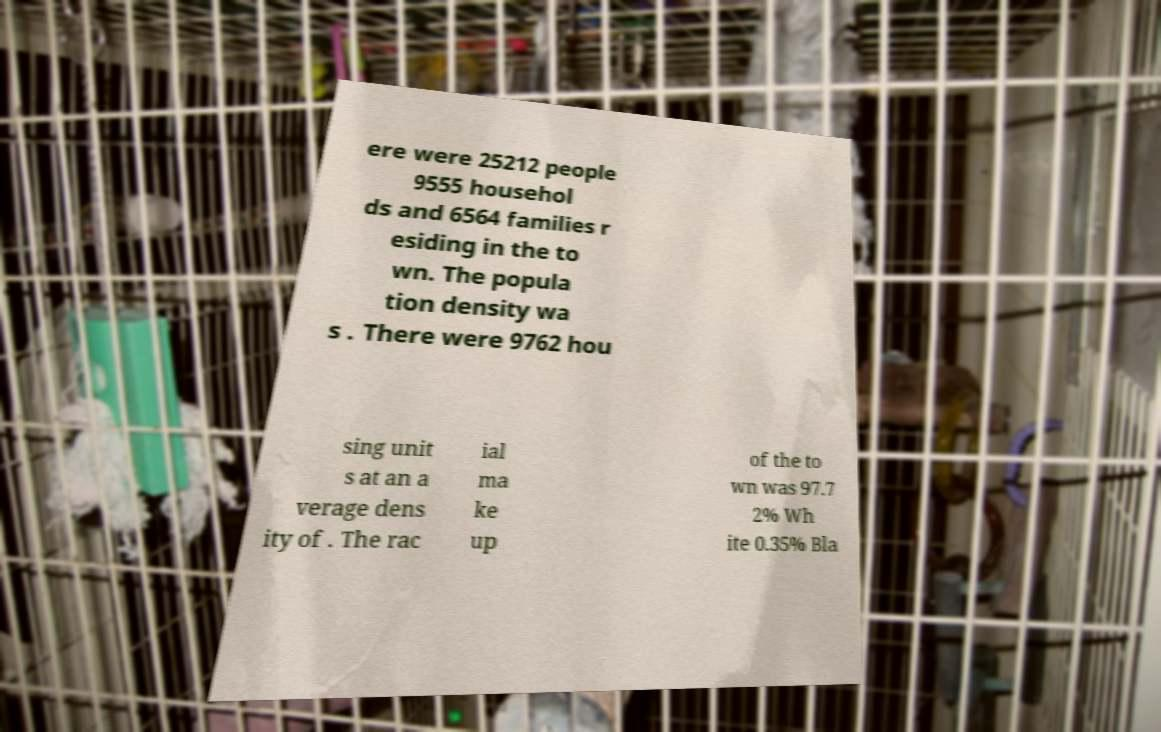Please read and relay the text visible in this image. What does it say? ere were 25212 people 9555 househol ds and 6564 families r esiding in the to wn. The popula tion density wa s . There were 9762 hou sing unit s at an a verage dens ity of . The rac ial ma ke up of the to wn was 97.7 2% Wh ite 0.35% Bla 